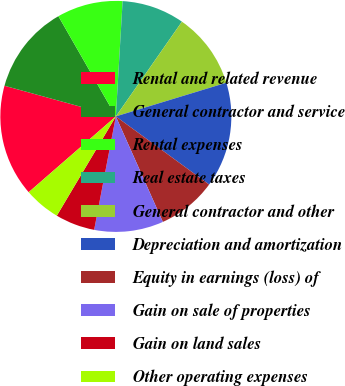<chart> <loc_0><loc_0><loc_500><loc_500><pie_chart><fcel>Rental and related revenue<fcel>General contractor and service<fcel>Rental expenses<fcel>Real estate taxes<fcel>General contractor and other<fcel>Depreciation and amortization<fcel>Equity in earnings (loss) of<fcel>Gain on sale of properties<fcel>Gain on land sales<fcel>Other operating expenses<nl><fcel>15.67%<fcel>12.44%<fcel>9.22%<fcel>8.76%<fcel>10.6%<fcel>14.75%<fcel>8.29%<fcel>9.68%<fcel>5.53%<fcel>5.07%<nl></chart> 